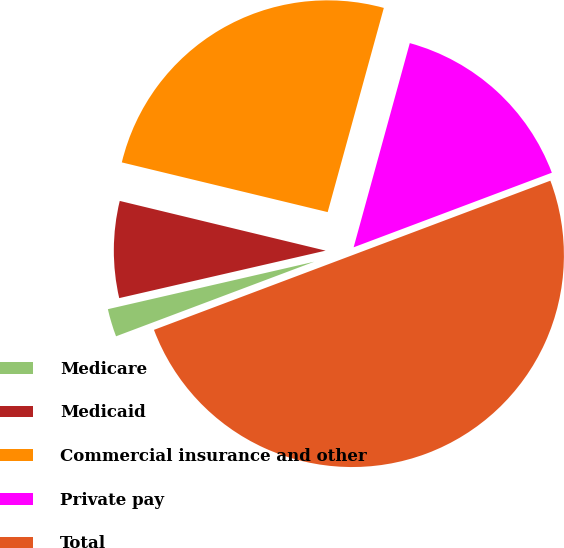<chart> <loc_0><loc_0><loc_500><loc_500><pie_chart><fcel>Medicare<fcel>Medicaid<fcel>Commercial insurance and other<fcel>Private pay<fcel>Total<nl><fcel>2.13%<fcel>7.37%<fcel>25.5%<fcel>15.0%<fcel>50.0%<nl></chart> 